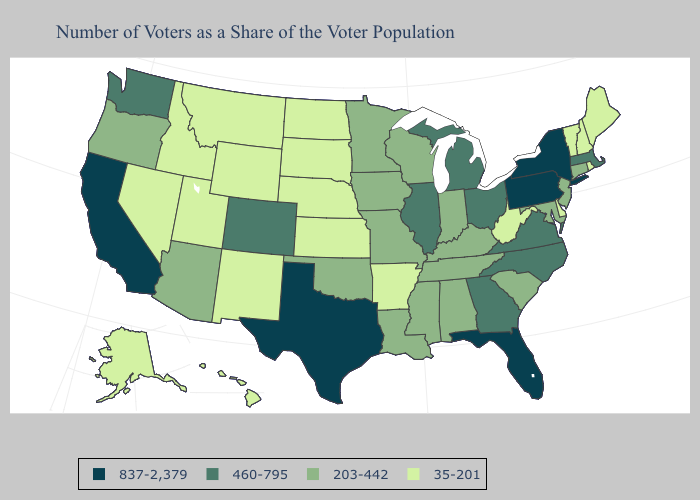What is the lowest value in states that border South Carolina?
Be succinct. 460-795. Which states hav the highest value in the Northeast?
Quick response, please. New York, Pennsylvania. What is the highest value in the MidWest ?
Keep it brief. 460-795. What is the lowest value in the Northeast?
Short answer required. 35-201. Does the first symbol in the legend represent the smallest category?
Keep it brief. No. Does Alabama have the same value as Kentucky?
Be succinct. Yes. What is the highest value in the USA?
Answer briefly. 837-2,379. What is the lowest value in the USA?
Concise answer only. 35-201. What is the value of Colorado?
Quick response, please. 460-795. What is the lowest value in the USA?
Quick response, please. 35-201. What is the highest value in states that border South Carolina?
Short answer required. 460-795. Name the states that have a value in the range 35-201?
Answer briefly. Alaska, Arkansas, Delaware, Hawaii, Idaho, Kansas, Maine, Montana, Nebraska, Nevada, New Hampshire, New Mexico, North Dakota, Rhode Island, South Dakota, Utah, Vermont, West Virginia, Wyoming. What is the value of Alabama?
Short answer required. 203-442. Among the states that border Connecticut , does Rhode Island have the lowest value?
Give a very brief answer. Yes. Which states hav the highest value in the Northeast?
Short answer required. New York, Pennsylvania. 